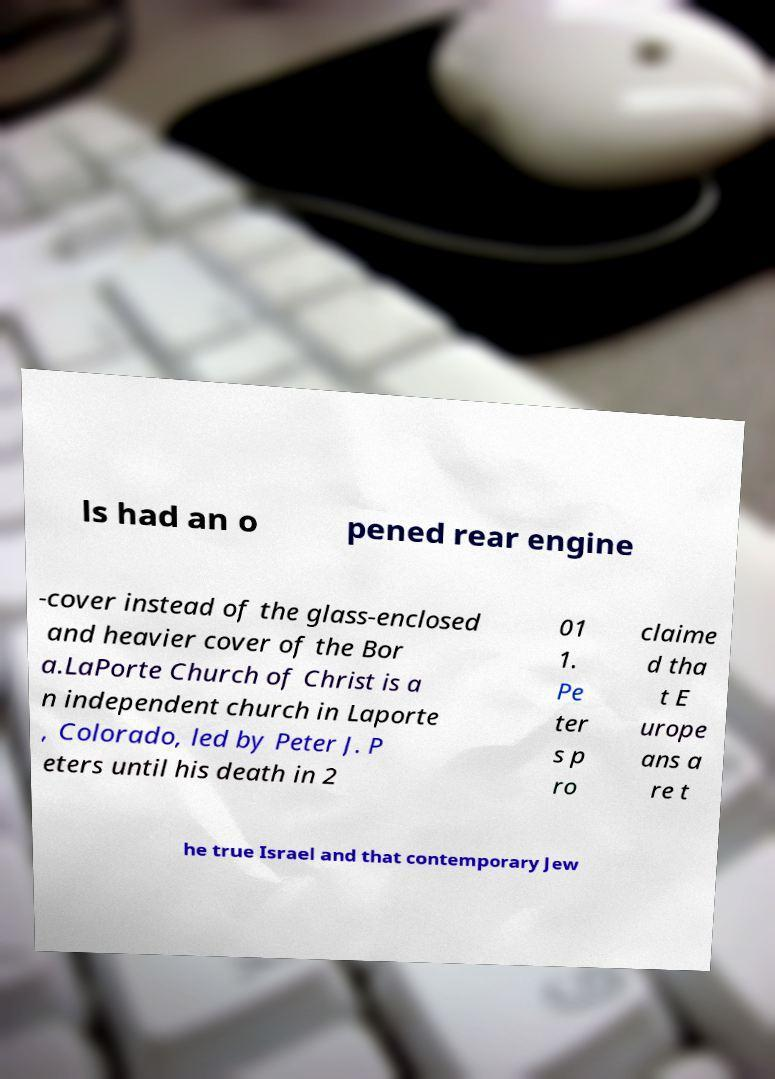I need the written content from this picture converted into text. Can you do that? ls had an o pened rear engine -cover instead of the glass-enclosed and heavier cover of the Bor a.LaPorte Church of Christ is a n independent church in Laporte , Colorado, led by Peter J. P eters until his death in 2 01 1. Pe ter s p ro claime d tha t E urope ans a re t he true Israel and that contemporary Jew 